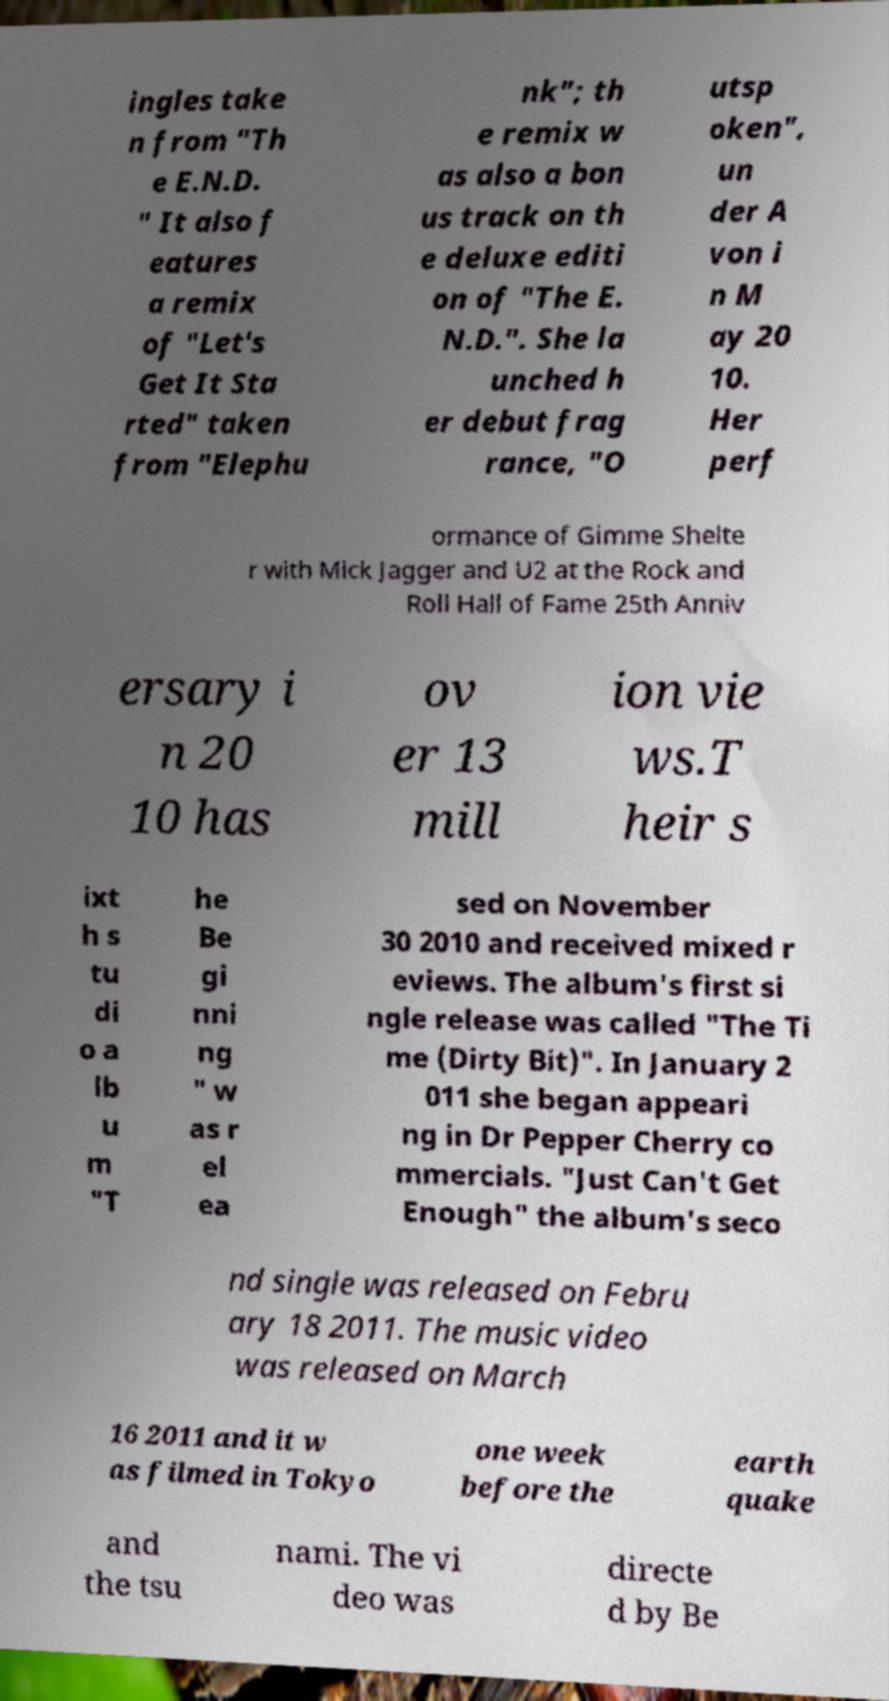Please identify and transcribe the text found in this image. ingles take n from "Th e E.N.D. " It also f eatures a remix of "Let's Get It Sta rted" taken from "Elephu nk"; th e remix w as also a bon us track on th e deluxe editi on of "The E. N.D.". She la unched h er debut frag rance, "O utsp oken", un der A von i n M ay 20 10. Her perf ormance of Gimme Shelte r with Mick Jagger and U2 at the Rock and Roll Hall of Fame 25th Anniv ersary i n 20 10 has ov er 13 mill ion vie ws.T heir s ixt h s tu di o a lb u m "T he Be gi nni ng " w as r el ea sed on November 30 2010 and received mixed r eviews. The album's first si ngle release was called "The Ti me (Dirty Bit)". In January 2 011 she began appeari ng in Dr Pepper Cherry co mmercials. "Just Can't Get Enough" the album's seco nd single was released on Febru ary 18 2011. The music video was released on March 16 2011 and it w as filmed in Tokyo one week before the earth quake and the tsu nami. The vi deo was directe d by Be 